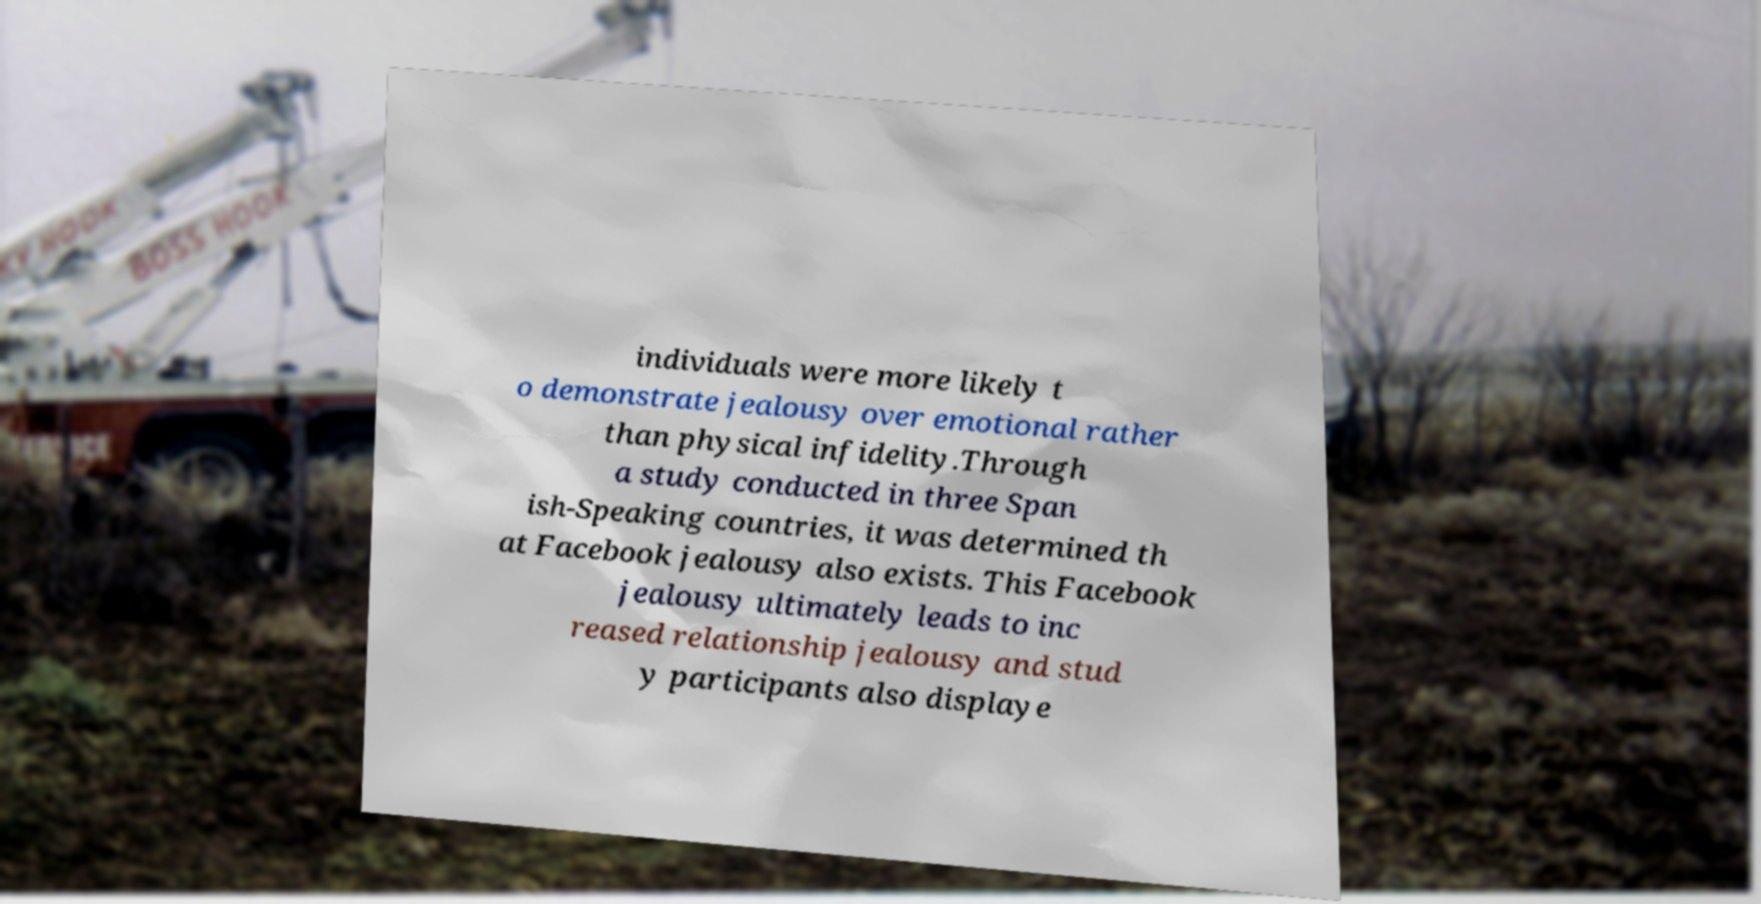What messages or text are displayed in this image? I need them in a readable, typed format. individuals were more likely t o demonstrate jealousy over emotional rather than physical infidelity.Through a study conducted in three Span ish-Speaking countries, it was determined th at Facebook jealousy also exists. This Facebook jealousy ultimately leads to inc reased relationship jealousy and stud y participants also displaye 